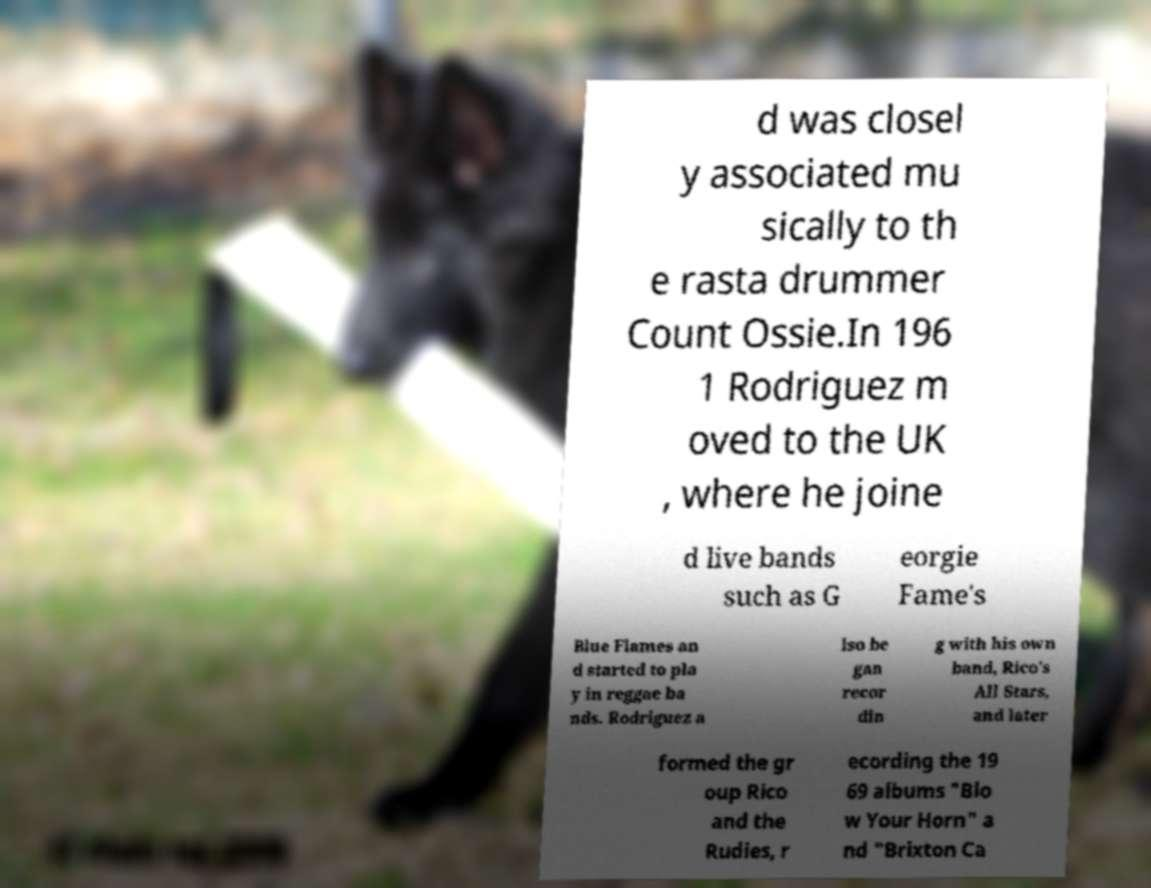Can you read and provide the text displayed in the image?This photo seems to have some interesting text. Can you extract and type it out for me? d was closel y associated mu sically to th e rasta drummer Count Ossie.In 196 1 Rodriguez m oved to the UK , where he joine d live bands such as G eorgie Fame's Blue Flames an d started to pla y in reggae ba nds. Rodriguez a lso be gan recor din g with his own band, Rico's All Stars, and later formed the gr oup Rico and the Rudies, r ecording the 19 69 albums "Blo w Your Horn" a nd "Brixton Ca 